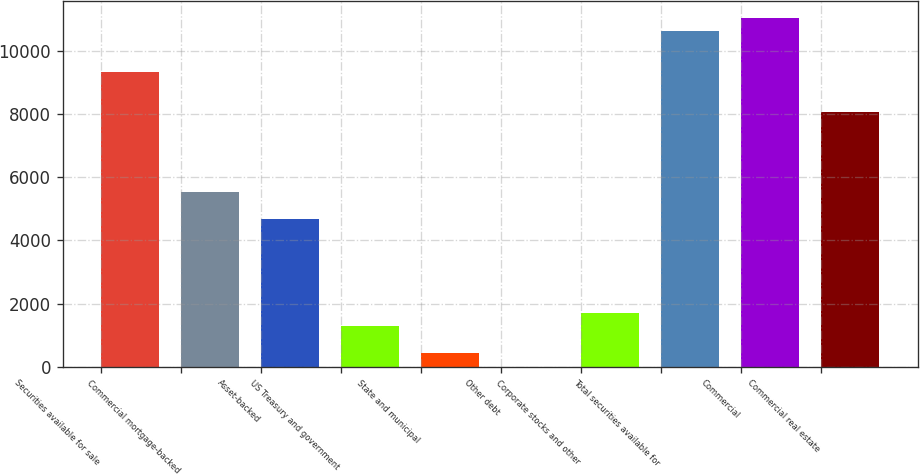<chart> <loc_0><loc_0><loc_500><loc_500><bar_chart><fcel>Securities available for sale<fcel>Commercial mortgage-backed<fcel>Asset-backed<fcel>US Treasury and government<fcel>State and municipal<fcel>Other debt<fcel>Corporate stocks and other<fcel>Total securities available for<fcel>Commercial<fcel>Commercial real estate<nl><fcel>9340.8<fcel>5521.2<fcel>4672.4<fcel>1277.2<fcel>428.4<fcel>4<fcel>1701.6<fcel>10614<fcel>11038.4<fcel>8067.6<nl></chart> 